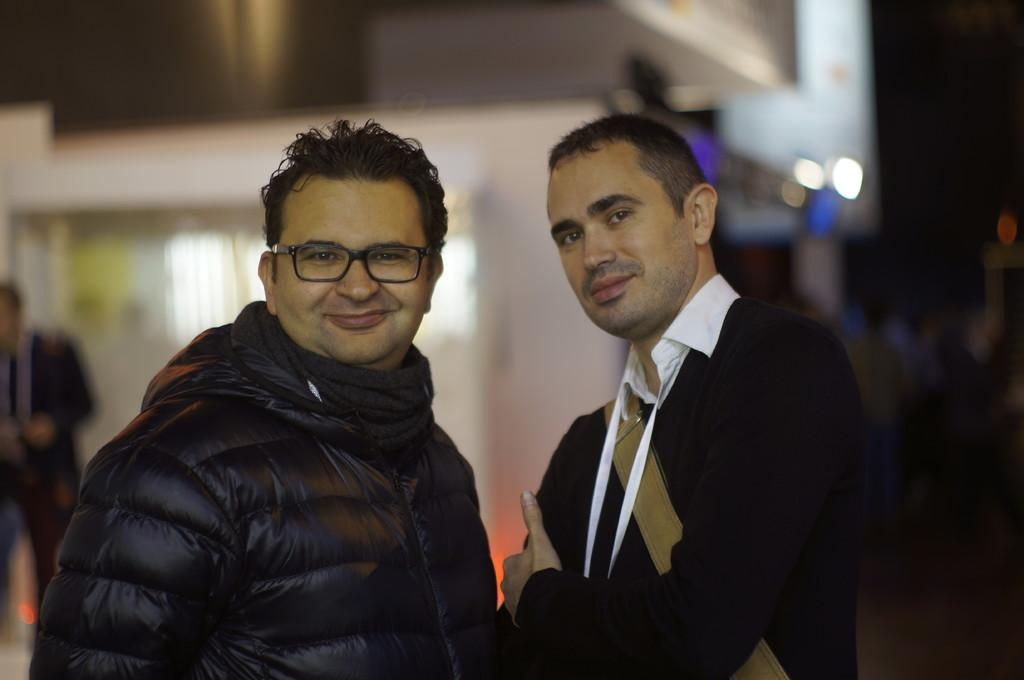What are the two persons in the center of the image doing? The two persons in the center of the image are standing and smiling. What can be observed about the person on the right side? The person on the right side is wearing a bag. Can you describe the person in the background of the image? There is a person standing in the background of the image. What type of fish can be seen swimming in the image? There is no fish present in the image. How many hens are visible in the image? There are no hens present in the image. 